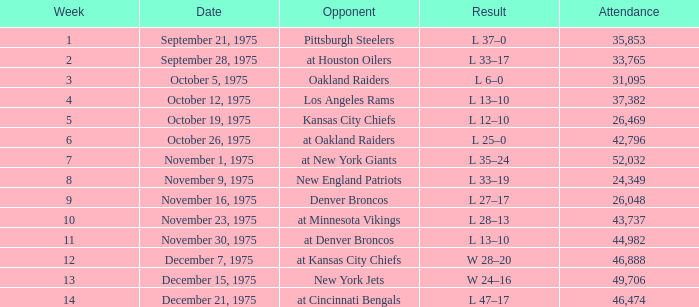What is the top week when the adversary was kansas city chiefs, with a crowd exceeding 26,469? None. 